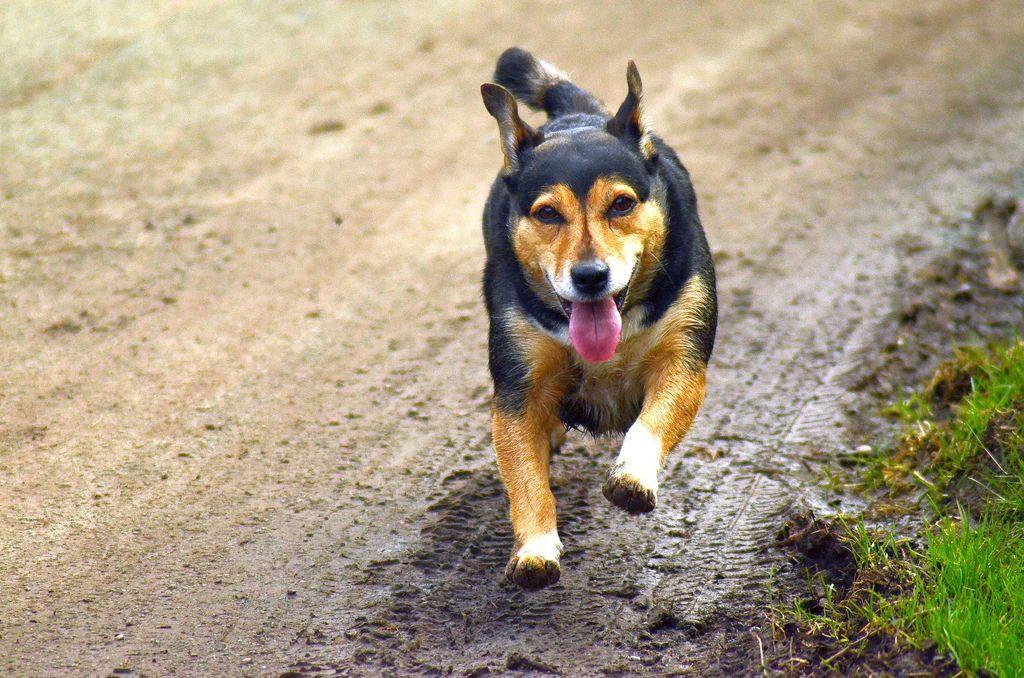Could you give a brief overview of what you see in this image? Here we can see a dog running on the ground and on the right side at the bottom corner we can see grass on the ground. 